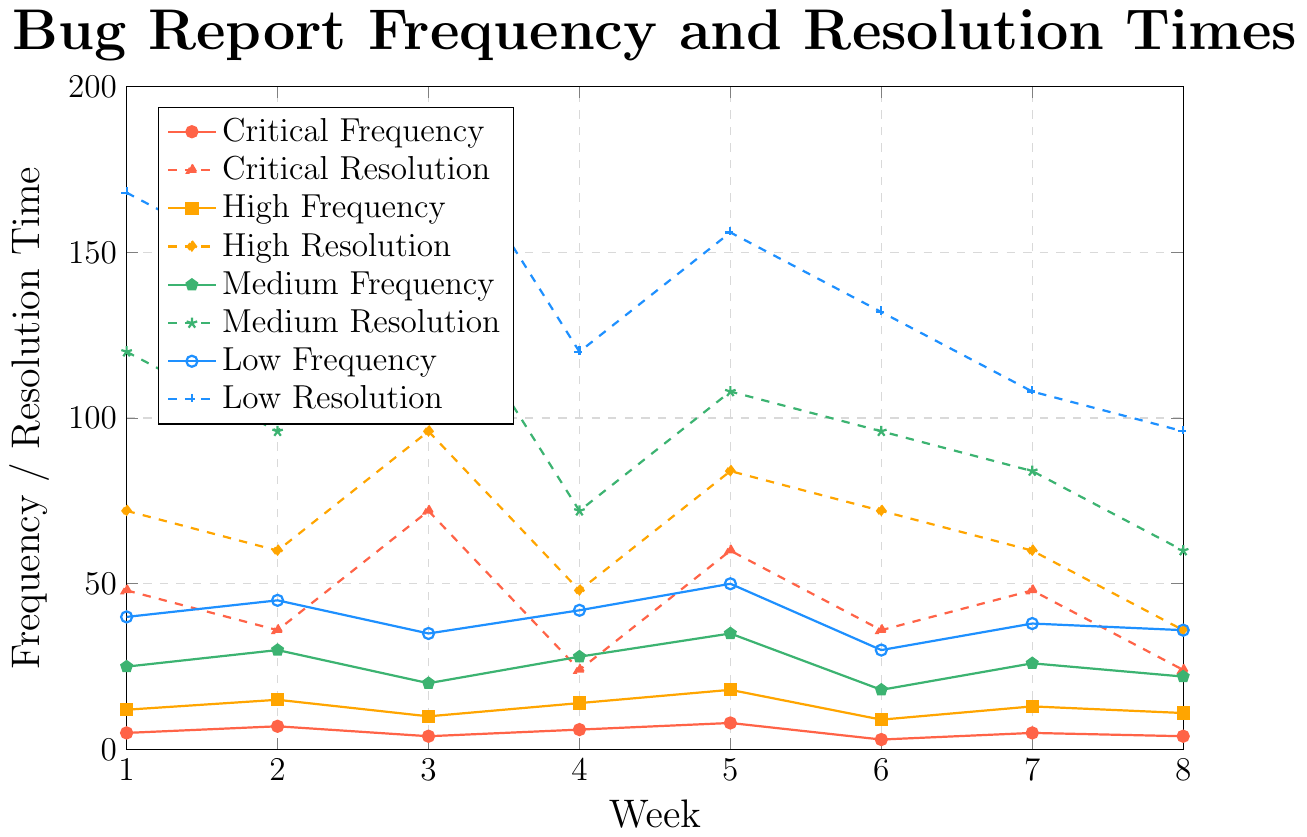What is the frequency of critical bug reports in Week 5? Look at the line marked with circles representing critical frequencies on the x-axis at Week 5. The y-value is 8.
Answer: 8 Which week shows the highest resolution time for medium severity bugs? Observe the line style and color marked for medium resolution times (green, dashed line with star markers). The highest y-value is 144 in Week 3.
Answer: Week 3 What is the difference in resolution times between high severity bugs in Week 6 and low severity bugs in Week 6? Identify the y-values of high severity resolution times (orange, diamond markers) and low severity resolution times (blue, plus markers) in Week 6. High = 72, Low = 132. The difference is 132 - 72 = 60.
Answer: 60 Among the severity levels, which has the most consistent frequency of bug reports across the weeks? Consistency can be seen by observing less fluctuation in the y-values. The medium frequency line (green, pentagons) has more consistent values compared to others.
Answer: Medium What is the average resolution time for critical bugs over the 8 weeks? Sum the resolution times for critical severity (48, 36, 72, 24, 60, 36, 48, 24) and divide by 8. (48 + 36 + 72 + 24 + 60 + 36 + 48 + 24) / 8 = 174 / 8 = 43.5
Answer: 43.5 Which week exhibits the lowest frequency of high severity bug reports? Observe the orange squares representing high frequency. The lowest y-value is 9 in Week 6.
Answer: Week 6 How does the frequency of low severity bugs in Week 1 compare to Week 8? Compare the y-values from the blue line marked with circles for Week 1 (40) and Week 8 (36). Week 1 has a higher frequency.
Answer: Week 1 has a higher frequency What is the total number of medium severity bug reports over the 8 weeks? Sum the frequencies for medium severity bugs across all weeks. 25 + 30 + 20 + 28 + 35 + 18 + 26 + 22 = 204.
Answer: 204 By how much does the resolution time for low severity bugs decrease from Week 1 to Week 8? Compare the resolution times (blue, plus markers) at Week 1 (168) and Week 8 (96). 168 - 96 = 72.
Answer: 72 What is the color used to represent the frequency of critical bug reports? Identify the line representing critical frequency. The color is red.
Answer: Red 